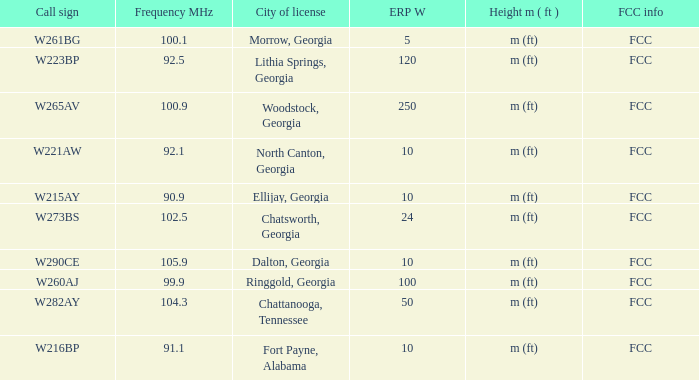What is the minimum erp w of w223bp? 120.0. 